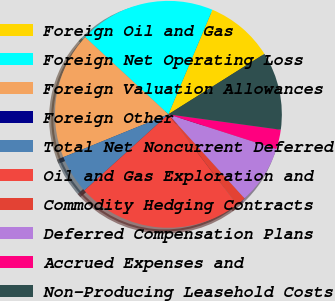Convert chart to OTSL. <chart><loc_0><loc_0><loc_500><loc_500><pie_chart><fcel>Foreign Oil and Gas<fcel>Foreign Net Operating Loss<fcel>Foreign Valuation Allowances<fcel>Foreign Other<fcel>Total Net Noncurrent Deferred<fcel>Oil and Gas Exploration and<fcel>Commodity Hedging Contracts<fcel>Deferred Compensation Plans<fcel>Accrued Expenses and<fcel>Non-Producing Leasehold Costs<nl><fcel>9.72%<fcel>19.44%<fcel>18.05%<fcel>0.0%<fcel>5.56%<fcel>23.61%<fcel>1.39%<fcel>8.33%<fcel>2.78%<fcel>11.11%<nl></chart> 